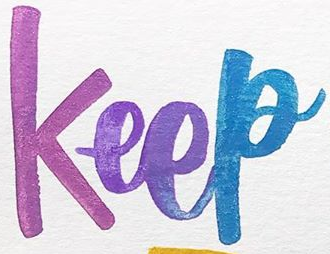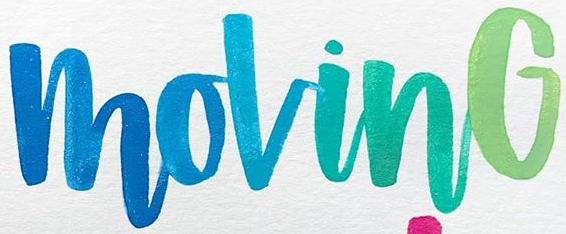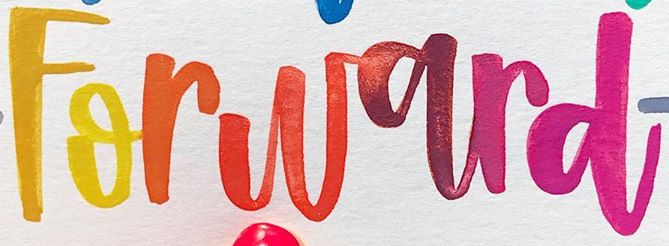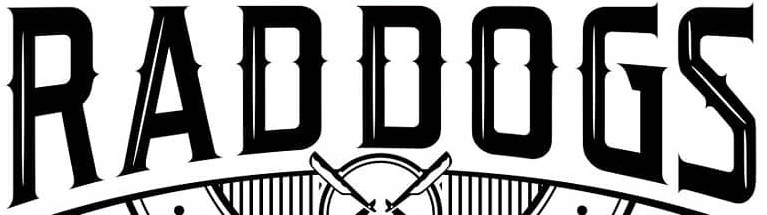Read the text from these images in sequence, separated by a semicolon. Keep; MovinG; Forward; RADDOGS 